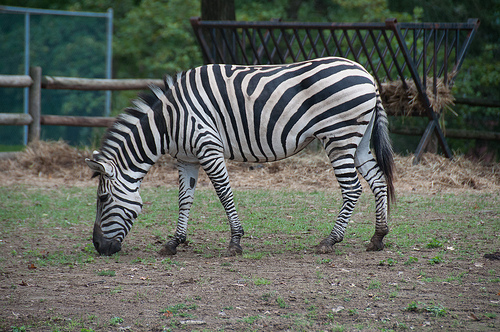Can you talk about the possible behaviors the zebra might be displaying given its posture in the image? The zebra's head is bent towards the ground, likely indicating grazing behavior. This natural posture suggests the zebra is in a relaxed state, comfortably feeding in its environment. 